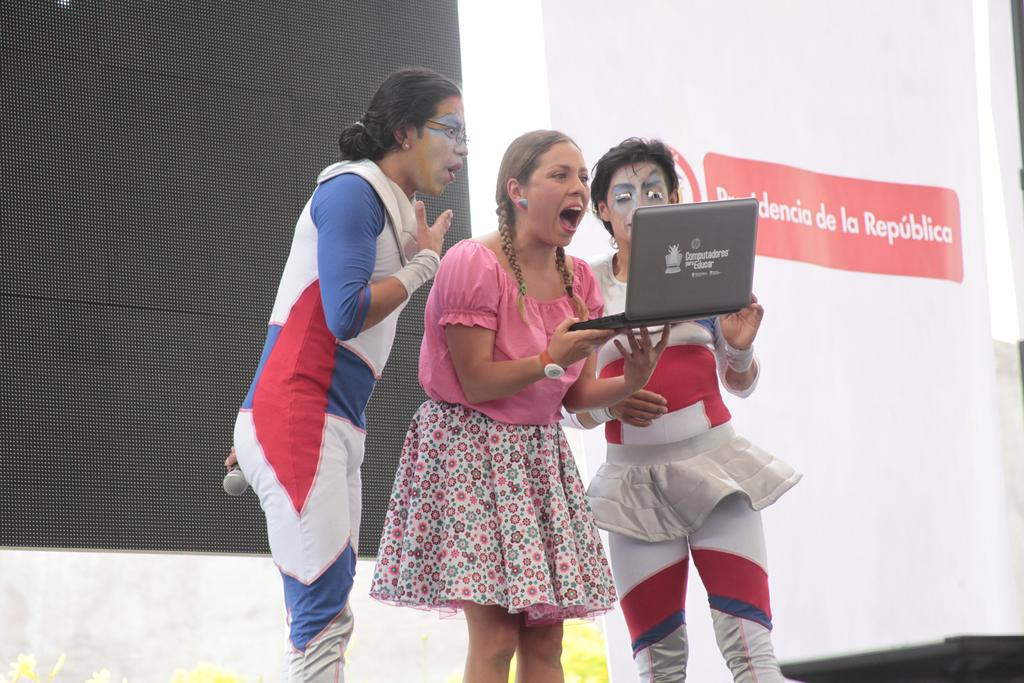How many women are present in the image? There are three women in the image. What are the women doing in the image? The women are standing and looking at a laptop screen. What are the women wearing in the image? Two of the women are wearing costumes. What can be seen on the right side of the image? There is a banner on the right side of the image. How much love is being expressed by the stranger in the image? There is no stranger present in the image, and therefore no expression of love can be observed. 